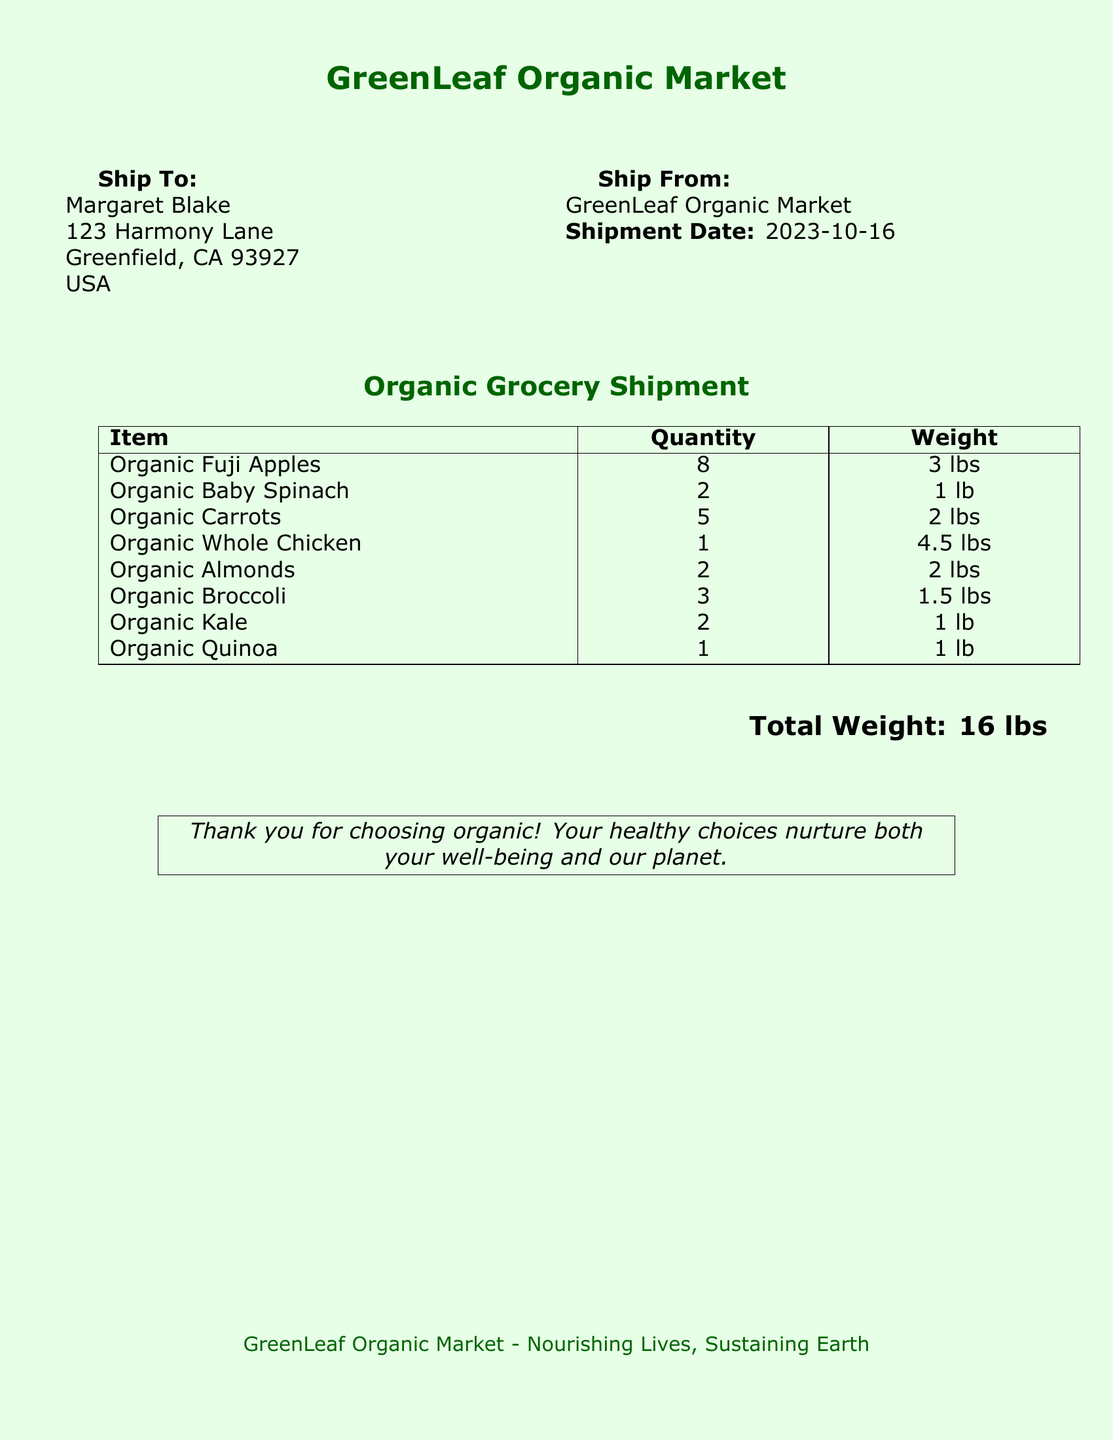What is the shipment date? The shipment date is specified in the document under the "Ship From" section as the date of shipment.
Answer: 2023-10-16 Who is the recipient of the shipment? The recipient's name is highlighted in the "Ship To" section where the individual is listed with their address.
Answer: Margaret Blake What items are included in the shipment? The document lists several items under the "Organic Grocery Shipment" section, detailing organic produce and products.
Answer: Organic Fuji Apples, Organic Baby Spinach, Organic Carrots, Organic Whole Chicken, Organic Almonds, Organic Broccoli, Organic Kale, Organic Quinoa What is the total weight of the shipment? The total weight is calculated and mentioned at the bottom of the document summarizing all items' weights.
Answer: 16 lbs How many organic chicken are included? The document specifies the quantity of organic whole chicken listed in the shipment details.
Answer: 1 What is the weight of the Organic Almonds? The weight is provided alongside the quantity of Organic Almonds listed in the itemized section of the document.
Answer: 2 lbs How many Fuji Apples are in the shipment? The quantity of Organic Fuji Apples is specifically listed in the table of items.
Answer: 8 What color theme is used for the document? The color theme is described at the beginning with a mention of the background color and text color used.
Answer: Light green, dark green 